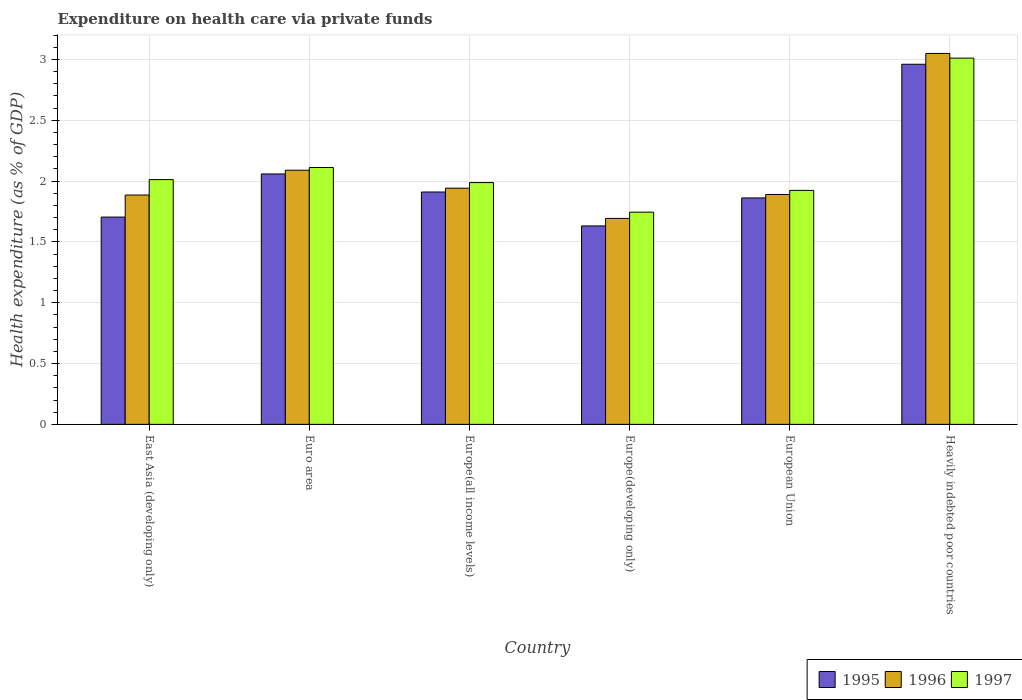How many different coloured bars are there?
Give a very brief answer. 3. Are the number of bars on each tick of the X-axis equal?
Provide a succinct answer. Yes. How many bars are there on the 6th tick from the left?
Keep it short and to the point. 3. How many bars are there on the 6th tick from the right?
Your answer should be very brief. 3. What is the label of the 1st group of bars from the left?
Offer a very short reply. East Asia (developing only). In how many cases, is the number of bars for a given country not equal to the number of legend labels?
Offer a terse response. 0. What is the expenditure made on health care in 1995 in Heavily indebted poor countries?
Offer a very short reply. 2.96. Across all countries, what is the maximum expenditure made on health care in 1996?
Offer a very short reply. 3.05. Across all countries, what is the minimum expenditure made on health care in 1995?
Offer a terse response. 1.63. In which country was the expenditure made on health care in 1995 maximum?
Your answer should be very brief. Heavily indebted poor countries. In which country was the expenditure made on health care in 1997 minimum?
Your answer should be very brief. Europe(developing only). What is the total expenditure made on health care in 1995 in the graph?
Your answer should be compact. 12.13. What is the difference between the expenditure made on health care in 1996 in Euro area and that in Europe(all income levels)?
Offer a very short reply. 0.15. What is the difference between the expenditure made on health care in 1997 in Heavily indebted poor countries and the expenditure made on health care in 1996 in Europe(all income levels)?
Provide a short and direct response. 1.07. What is the average expenditure made on health care in 1995 per country?
Provide a short and direct response. 2.02. What is the difference between the expenditure made on health care of/in 1996 and expenditure made on health care of/in 1997 in European Union?
Offer a terse response. -0.03. In how many countries, is the expenditure made on health care in 1996 greater than 0.30000000000000004 %?
Offer a terse response. 6. What is the ratio of the expenditure made on health care in 1997 in East Asia (developing only) to that in Heavily indebted poor countries?
Keep it short and to the point. 0.67. Is the expenditure made on health care in 1995 in Europe(all income levels) less than that in Europe(developing only)?
Offer a very short reply. No. What is the difference between the highest and the second highest expenditure made on health care in 1997?
Keep it short and to the point. -0.1. What is the difference between the highest and the lowest expenditure made on health care in 1996?
Provide a succinct answer. 1.36. In how many countries, is the expenditure made on health care in 1995 greater than the average expenditure made on health care in 1995 taken over all countries?
Your answer should be very brief. 2. How many bars are there?
Your answer should be compact. 18. Are all the bars in the graph horizontal?
Make the answer very short. No. How many countries are there in the graph?
Ensure brevity in your answer.  6. What is the difference between two consecutive major ticks on the Y-axis?
Provide a succinct answer. 0.5. Does the graph contain any zero values?
Provide a succinct answer. No. Does the graph contain grids?
Make the answer very short. Yes. Where does the legend appear in the graph?
Offer a terse response. Bottom right. How are the legend labels stacked?
Offer a very short reply. Horizontal. What is the title of the graph?
Make the answer very short. Expenditure on health care via private funds. Does "1987" appear as one of the legend labels in the graph?
Ensure brevity in your answer.  No. What is the label or title of the X-axis?
Make the answer very short. Country. What is the label or title of the Y-axis?
Offer a very short reply. Health expenditure (as % of GDP). What is the Health expenditure (as % of GDP) of 1995 in East Asia (developing only)?
Make the answer very short. 1.7. What is the Health expenditure (as % of GDP) in 1996 in East Asia (developing only)?
Offer a terse response. 1.89. What is the Health expenditure (as % of GDP) in 1997 in East Asia (developing only)?
Your answer should be compact. 2.01. What is the Health expenditure (as % of GDP) of 1995 in Euro area?
Your response must be concise. 2.06. What is the Health expenditure (as % of GDP) in 1996 in Euro area?
Provide a short and direct response. 2.09. What is the Health expenditure (as % of GDP) in 1997 in Euro area?
Provide a succinct answer. 2.11. What is the Health expenditure (as % of GDP) of 1995 in Europe(all income levels)?
Provide a succinct answer. 1.91. What is the Health expenditure (as % of GDP) of 1996 in Europe(all income levels)?
Your answer should be compact. 1.94. What is the Health expenditure (as % of GDP) in 1997 in Europe(all income levels)?
Give a very brief answer. 1.99. What is the Health expenditure (as % of GDP) of 1995 in Europe(developing only)?
Keep it short and to the point. 1.63. What is the Health expenditure (as % of GDP) of 1996 in Europe(developing only)?
Offer a very short reply. 1.69. What is the Health expenditure (as % of GDP) of 1997 in Europe(developing only)?
Provide a short and direct response. 1.74. What is the Health expenditure (as % of GDP) of 1995 in European Union?
Keep it short and to the point. 1.86. What is the Health expenditure (as % of GDP) of 1996 in European Union?
Ensure brevity in your answer.  1.89. What is the Health expenditure (as % of GDP) of 1997 in European Union?
Your answer should be very brief. 1.92. What is the Health expenditure (as % of GDP) in 1995 in Heavily indebted poor countries?
Keep it short and to the point. 2.96. What is the Health expenditure (as % of GDP) in 1996 in Heavily indebted poor countries?
Offer a terse response. 3.05. What is the Health expenditure (as % of GDP) of 1997 in Heavily indebted poor countries?
Your answer should be compact. 3.01. Across all countries, what is the maximum Health expenditure (as % of GDP) of 1995?
Offer a terse response. 2.96. Across all countries, what is the maximum Health expenditure (as % of GDP) of 1996?
Give a very brief answer. 3.05. Across all countries, what is the maximum Health expenditure (as % of GDP) of 1997?
Provide a succinct answer. 3.01. Across all countries, what is the minimum Health expenditure (as % of GDP) in 1995?
Provide a short and direct response. 1.63. Across all countries, what is the minimum Health expenditure (as % of GDP) of 1996?
Your answer should be very brief. 1.69. Across all countries, what is the minimum Health expenditure (as % of GDP) in 1997?
Keep it short and to the point. 1.74. What is the total Health expenditure (as % of GDP) of 1995 in the graph?
Provide a succinct answer. 12.13. What is the total Health expenditure (as % of GDP) of 1996 in the graph?
Make the answer very short. 12.55. What is the total Health expenditure (as % of GDP) in 1997 in the graph?
Provide a succinct answer. 12.79. What is the difference between the Health expenditure (as % of GDP) of 1995 in East Asia (developing only) and that in Euro area?
Offer a very short reply. -0.35. What is the difference between the Health expenditure (as % of GDP) in 1996 in East Asia (developing only) and that in Euro area?
Make the answer very short. -0.2. What is the difference between the Health expenditure (as % of GDP) in 1997 in East Asia (developing only) and that in Euro area?
Offer a very short reply. -0.1. What is the difference between the Health expenditure (as % of GDP) in 1995 in East Asia (developing only) and that in Europe(all income levels)?
Your answer should be very brief. -0.21. What is the difference between the Health expenditure (as % of GDP) in 1996 in East Asia (developing only) and that in Europe(all income levels)?
Offer a very short reply. -0.06. What is the difference between the Health expenditure (as % of GDP) of 1997 in East Asia (developing only) and that in Europe(all income levels)?
Give a very brief answer. 0.02. What is the difference between the Health expenditure (as % of GDP) of 1995 in East Asia (developing only) and that in Europe(developing only)?
Offer a terse response. 0.07. What is the difference between the Health expenditure (as % of GDP) in 1996 in East Asia (developing only) and that in Europe(developing only)?
Provide a succinct answer. 0.19. What is the difference between the Health expenditure (as % of GDP) of 1997 in East Asia (developing only) and that in Europe(developing only)?
Provide a short and direct response. 0.27. What is the difference between the Health expenditure (as % of GDP) in 1995 in East Asia (developing only) and that in European Union?
Keep it short and to the point. -0.16. What is the difference between the Health expenditure (as % of GDP) in 1996 in East Asia (developing only) and that in European Union?
Ensure brevity in your answer.  -0. What is the difference between the Health expenditure (as % of GDP) in 1997 in East Asia (developing only) and that in European Union?
Provide a short and direct response. 0.09. What is the difference between the Health expenditure (as % of GDP) in 1995 in East Asia (developing only) and that in Heavily indebted poor countries?
Ensure brevity in your answer.  -1.26. What is the difference between the Health expenditure (as % of GDP) of 1996 in East Asia (developing only) and that in Heavily indebted poor countries?
Ensure brevity in your answer.  -1.16. What is the difference between the Health expenditure (as % of GDP) in 1997 in East Asia (developing only) and that in Heavily indebted poor countries?
Your answer should be compact. -1. What is the difference between the Health expenditure (as % of GDP) in 1995 in Euro area and that in Europe(all income levels)?
Make the answer very short. 0.15. What is the difference between the Health expenditure (as % of GDP) in 1996 in Euro area and that in Europe(all income levels)?
Your answer should be compact. 0.15. What is the difference between the Health expenditure (as % of GDP) of 1997 in Euro area and that in Europe(all income levels)?
Make the answer very short. 0.12. What is the difference between the Health expenditure (as % of GDP) of 1995 in Euro area and that in Europe(developing only)?
Your answer should be compact. 0.43. What is the difference between the Health expenditure (as % of GDP) in 1996 in Euro area and that in Europe(developing only)?
Give a very brief answer. 0.4. What is the difference between the Health expenditure (as % of GDP) in 1997 in Euro area and that in Europe(developing only)?
Keep it short and to the point. 0.37. What is the difference between the Health expenditure (as % of GDP) in 1995 in Euro area and that in European Union?
Your answer should be compact. 0.2. What is the difference between the Health expenditure (as % of GDP) in 1996 in Euro area and that in European Union?
Your answer should be compact. 0.2. What is the difference between the Health expenditure (as % of GDP) in 1997 in Euro area and that in European Union?
Offer a terse response. 0.19. What is the difference between the Health expenditure (as % of GDP) in 1995 in Euro area and that in Heavily indebted poor countries?
Provide a succinct answer. -0.9. What is the difference between the Health expenditure (as % of GDP) of 1996 in Euro area and that in Heavily indebted poor countries?
Ensure brevity in your answer.  -0.96. What is the difference between the Health expenditure (as % of GDP) in 1997 in Euro area and that in Heavily indebted poor countries?
Your answer should be very brief. -0.9. What is the difference between the Health expenditure (as % of GDP) in 1995 in Europe(all income levels) and that in Europe(developing only)?
Your response must be concise. 0.28. What is the difference between the Health expenditure (as % of GDP) in 1996 in Europe(all income levels) and that in Europe(developing only)?
Ensure brevity in your answer.  0.25. What is the difference between the Health expenditure (as % of GDP) of 1997 in Europe(all income levels) and that in Europe(developing only)?
Provide a succinct answer. 0.24. What is the difference between the Health expenditure (as % of GDP) in 1995 in Europe(all income levels) and that in European Union?
Provide a short and direct response. 0.05. What is the difference between the Health expenditure (as % of GDP) of 1996 in Europe(all income levels) and that in European Union?
Provide a succinct answer. 0.05. What is the difference between the Health expenditure (as % of GDP) of 1997 in Europe(all income levels) and that in European Union?
Offer a very short reply. 0.06. What is the difference between the Health expenditure (as % of GDP) in 1995 in Europe(all income levels) and that in Heavily indebted poor countries?
Offer a terse response. -1.05. What is the difference between the Health expenditure (as % of GDP) of 1996 in Europe(all income levels) and that in Heavily indebted poor countries?
Ensure brevity in your answer.  -1.11. What is the difference between the Health expenditure (as % of GDP) in 1997 in Europe(all income levels) and that in Heavily indebted poor countries?
Give a very brief answer. -1.02. What is the difference between the Health expenditure (as % of GDP) of 1995 in Europe(developing only) and that in European Union?
Provide a short and direct response. -0.23. What is the difference between the Health expenditure (as % of GDP) in 1996 in Europe(developing only) and that in European Union?
Offer a terse response. -0.2. What is the difference between the Health expenditure (as % of GDP) in 1997 in Europe(developing only) and that in European Union?
Offer a terse response. -0.18. What is the difference between the Health expenditure (as % of GDP) of 1995 in Europe(developing only) and that in Heavily indebted poor countries?
Make the answer very short. -1.33. What is the difference between the Health expenditure (as % of GDP) of 1996 in Europe(developing only) and that in Heavily indebted poor countries?
Your answer should be very brief. -1.36. What is the difference between the Health expenditure (as % of GDP) of 1997 in Europe(developing only) and that in Heavily indebted poor countries?
Ensure brevity in your answer.  -1.27. What is the difference between the Health expenditure (as % of GDP) of 1995 in European Union and that in Heavily indebted poor countries?
Your response must be concise. -1.1. What is the difference between the Health expenditure (as % of GDP) of 1996 in European Union and that in Heavily indebted poor countries?
Keep it short and to the point. -1.16. What is the difference between the Health expenditure (as % of GDP) of 1997 in European Union and that in Heavily indebted poor countries?
Make the answer very short. -1.09. What is the difference between the Health expenditure (as % of GDP) in 1995 in East Asia (developing only) and the Health expenditure (as % of GDP) in 1996 in Euro area?
Offer a terse response. -0.39. What is the difference between the Health expenditure (as % of GDP) in 1995 in East Asia (developing only) and the Health expenditure (as % of GDP) in 1997 in Euro area?
Ensure brevity in your answer.  -0.41. What is the difference between the Health expenditure (as % of GDP) of 1996 in East Asia (developing only) and the Health expenditure (as % of GDP) of 1997 in Euro area?
Make the answer very short. -0.23. What is the difference between the Health expenditure (as % of GDP) in 1995 in East Asia (developing only) and the Health expenditure (as % of GDP) in 1996 in Europe(all income levels)?
Your response must be concise. -0.24. What is the difference between the Health expenditure (as % of GDP) of 1995 in East Asia (developing only) and the Health expenditure (as % of GDP) of 1997 in Europe(all income levels)?
Keep it short and to the point. -0.28. What is the difference between the Health expenditure (as % of GDP) in 1996 in East Asia (developing only) and the Health expenditure (as % of GDP) in 1997 in Europe(all income levels)?
Provide a short and direct response. -0.1. What is the difference between the Health expenditure (as % of GDP) of 1995 in East Asia (developing only) and the Health expenditure (as % of GDP) of 1996 in Europe(developing only)?
Your answer should be compact. 0.01. What is the difference between the Health expenditure (as % of GDP) in 1995 in East Asia (developing only) and the Health expenditure (as % of GDP) in 1997 in Europe(developing only)?
Provide a succinct answer. -0.04. What is the difference between the Health expenditure (as % of GDP) of 1996 in East Asia (developing only) and the Health expenditure (as % of GDP) of 1997 in Europe(developing only)?
Provide a succinct answer. 0.14. What is the difference between the Health expenditure (as % of GDP) in 1995 in East Asia (developing only) and the Health expenditure (as % of GDP) in 1996 in European Union?
Provide a short and direct response. -0.19. What is the difference between the Health expenditure (as % of GDP) in 1995 in East Asia (developing only) and the Health expenditure (as % of GDP) in 1997 in European Union?
Provide a short and direct response. -0.22. What is the difference between the Health expenditure (as % of GDP) of 1996 in East Asia (developing only) and the Health expenditure (as % of GDP) of 1997 in European Union?
Keep it short and to the point. -0.04. What is the difference between the Health expenditure (as % of GDP) in 1995 in East Asia (developing only) and the Health expenditure (as % of GDP) in 1996 in Heavily indebted poor countries?
Keep it short and to the point. -1.35. What is the difference between the Health expenditure (as % of GDP) of 1995 in East Asia (developing only) and the Health expenditure (as % of GDP) of 1997 in Heavily indebted poor countries?
Offer a very short reply. -1.31. What is the difference between the Health expenditure (as % of GDP) in 1996 in East Asia (developing only) and the Health expenditure (as % of GDP) in 1997 in Heavily indebted poor countries?
Your answer should be very brief. -1.13. What is the difference between the Health expenditure (as % of GDP) of 1995 in Euro area and the Health expenditure (as % of GDP) of 1996 in Europe(all income levels)?
Your answer should be very brief. 0.12. What is the difference between the Health expenditure (as % of GDP) of 1995 in Euro area and the Health expenditure (as % of GDP) of 1997 in Europe(all income levels)?
Keep it short and to the point. 0.07. What is the difference between the Health expenditure (as % of GDP) of 1996 in Euro area and the Health expenditure (as % of GDP) of 1997 in Europe(all income levels)?
Offer a very short reply. 0.1. What is the difference between the Health expenditure (as % of GDP) of 1995 in Euro area and the Health expenditure (as % of GDP) of 1996 in Europe(developing only)?
Make the answer very short. 0.37. What is the difference between the Health expenditure (as % of GDP) in 1995 in Euro area and the Health expenditure (as % of GDP) in 1997 in Europe(developing only)?
Ensure brevity in your answer.  0.31. What is the difference between the Health expenditure (as % of GDP) in 1996 in Euro area and the Health expenditure (as % of GDP) in 1997 in Europe(developing only)?
Give a very brief answer. 0.34. What is the difference between the Health expenditure (as % of GDP) of 1995 in Euro area and the Health expenditure (as % of GDP) of 1996 in European Union?
Provide a short and direct response. 0.17. What is the difference between the Health expenditure (as % of GDP) of 1995 in Euro area and the Health expenditure (as % of GDP) of 1997 in European Union?
Make the answer very short. 0.14. What is the difference between the Health expenditure (as % of GDP) in 1996 in Euro area and the Health expenditure (as % of GDP) in 1997 in European Union?
Give a very brief answer. 0.17. What is the difference between the Health expenditure (as % of GDP) of 1995 in Euro area and the Health expenditure (as % of GDP) of 1996 in Heavily indebted poor countries?
Keep it short and to the point. -0.99. What is the difference between the Health expenditure (as % of GDP) in 1995 in Euro area and the Health expenditure (as % of GDP) in 1997 in Heavily indebted poor countries?
Ensure brevity in your answer.  -0.95. What is the difference between the Health expenditure (as % of GDP) in 1996 in Euro area and the Health expenditure (as % of GDP) in 1997 in Heavily indebted poor countries?
Offer a very short reply. -0.92. What is the difference between the Health expenditure (as % of GDP) in 1995 in Europe(all income levels) and the Health expenditure (as % of GDP) in 1996 in Europe(developing only)?
Offer a terse response. 0.22. What is the difference between the Health expenditure (as % of GDP) of 1995 in Europe(all income levels) and the Health expenditure (as % of GDP) of 1997 in Europe(developing only)?
Your answer should be very brief. 0.17. What is the difference between the Health expenditure (as % of GDP) of 1996 in Europe(all income levels) and the Health expenditure (as % of GDP) of 1997 in Europe(developing only)?
Your response must be concise. 0.2. What is the difference between the Health expenditure (as % of GDP) of 1995 in Europe(all income levels) and the Health expenditure (as % of GDP) of 1996 in European Union?
Offer a very short reply. 0.02. What is the difference between the Health expenditure (as % of GDP) in 1995 in Europe(all income levels) and the Health expenditure (as % of GDP) in 1997 in European Union?
Your answer should be compact. -0.01. What is the difference between the Health expenditure (as % of GDP) in 1996 in Europe(all income levels) and the Health expenditure (as % of GDP) in 1997 in European Union?
Provide a short and direct response. 0.02. What is the difference between the Health expenditure (as % of GDP) of 1995 in Europe(all income levels) and the Health expenditure (as % of GDP) of 1996 in Heavily indebted poor countries?
Your response must be concise. -1.14. What is the difference between the Health expenditure (as % of GDP) in 1995 in Europe(all income levels) and the Health expenditure (as % of GDP) in 1997 in Heavily indebted poor countries?
Give a very brief answer. -1.1. What is the difference between the Health expenditure (as % of GDP) of 1996 in Europe(all income levels) and the Health expenditure (as % of GDP) of 1997 in Heavily indebted poor countries?
Your response must be concise. -1.07. What is the difference between the Health expenditure (as % of GDP) in 1995 in Europe(developing only) and the Health expenditure (as % of GDP) in 1996 in European Union?
Make the answer very short. -0.26. What is the difference between the Health expenditure (as % of GDP) of 1995 in Europe(developing only) and the Health expenditure (as % of GDP) of 1997 in European Union?
Your answer should be compact. -0.29. What is the difference between the Health expenditure (as % of GDP) in 1996 in Europe(developing only) and the Health expenditure (as % of GDP) in 1997 in European Union?
Your answer should be compact. -0.23. What is the difference between the Health expenditure (as % of GDP) in 1995 in Europe(developing only) and the Health expenditure (as % of GDP) in 1996 in Heavily indebted poor countries?
Your response must be concise. -1.42. What is the difference between the Health expenditure (as % of GDP) of 1995 in Europe(developing only) and the Health expenditure (as % of GDP) of 1997 in Heavily indebted poor countries?
Ensure brevity in your answer.  -1.38. What is the difference between the Health expenditure (as % of GDP) in 1996 in Europe(developing only) and the Health expenditure (as % of GDP) in 1997 in Heavily indebted poor countries?
Make the answer very short. -1.32. What is the difference between the Health expenditure (as % of GDP) in 1995 in European Union and the Health expenditure (as % of GDP) in 1996 in Heavily indebted poor countries?
Offer a very short reply. -1.19. What is the difference between the Health expenditure (as % of GDP) in 1995 in European Union and the Health expenditure (as % of GDP) in 1997 in Heavily indebted poor countries?
Offer a very short reply. -1.15. What is the difference between the Health expenditure (as % of GDP) in 1996 in European Union and the Health expenditure (as % of GDP) in 1997 in Heavily indebted poor countries?
Provide a short and direct response. -1.12. What is the average Health expenditure (as % of GDP) in 1995 per country?
Your answer should be very brief. 2.02. What is the average Health expenditure (as % of GDP) of 1996 per country?
Ensure brevity in your answer.  2.09. What is the average Health expenditure (as % of GDP) in 1997 per country?
Your response must be concise. 2.13. What is the difference between the Health expenditure (as % of GDP) in 1995 and Health expenditure (as % of GDP) in 1996 in East Asia (developing only)?
Provide a short and direct response. -0.18. What is the difference between the Health expenditure (as % of GDP) of 1995 and Health expenditure (as % of GDP) of 1997 in East Asia (developing only)?
Ensure brevity in your answer.  -0.31. What is the difference between the Health expenditure (as % of GDP) of 1996 and Health expenditure (as % of GDP) of 1997 in East Asia (developing only)?
Your response must be concise. -0.13. What is the difference between the Health expenditure (as % of GDP) in 1995 and Health expenditure (as % of GDP) in 1996 in Euro area?
Provide a succinct answer. -0.03. What is the difference between the Health expenditure (as % of GDP) of 1995 and Health expenditure (as % of GDP) of 1997 in Euro area?
Give a very brief answer. -0.05. What is the difference between the Health expenditure (as % of GDP) of 1996 and Health expenditure (as % of GDP) of 1997 in Euro area?
Your answer should be compact. -0.02. What is the difference between the Health expenditure (as % of GDP) in 1995 and Health expenditure (as % of GDP) in 1996 in Europe(all income levels)?
Provide a short and direct response. -0.03. What is the difference between the Health expenditure (as % of GDP) of 1995 and Health expenditure (as % of GDP) of 1997 in Europe(all income levels)?
Your answer should be very brief. -0.08. What is the difference between the Health expenditure (as % of GDP) in 1996 and Health expenditure (as % of GDP) in 1997 in Europe(all income levels)?
Your answer should be compact. -0.05. What is the difference between the Health expenditure (as % of GDP) of 1995 and Health expenditure (as % of GDP) of 1996 in Europe(developing only)?
Give a very brief answer. -0.06. What is the difference between the Health expenditure (as % of GDP) in 1995 and Health expenditure (as % of GDP) in 1997 in Europe(developing only)?
Give a very brief answer. -0.11. What is the difference between the Health expenditure (as % of GDP) of 1996 and Health expenditure (as % of GDP) of 1997 in Europe(developing only)?
Your answer should be compact. -0.05. What is the difference between the Health expenditure (as % of GDP) of 1995 and Health expenditure (as % of GDP) of 1996 in European Union?
Make the answer very short. -0.03. What is the difference between the Health expenditure (as % of GDP) of 1995 and Health expenditure (as % of GDP) of 1997 in European Union?
Give a very brief answer. -0.06. What is the difference between the Health expenditure (as % of GDP) of 1996 and Health expenditure (as % of GDP) of 1997 in European Union?
Keep it short and to the point. -0.03. What is the difference between the Health expenditure (as % of GDP) of 1995 and Health expenditure (as % of GDP) of 1996 in Heavily indebted poor countries?
Your answer should be very brief. -0.09. What is the difference between the Health expenditure (as % of GDP) of 1995 and Health expenditure (as % of GDP) of 1997 in Heavily indebted poor countries?
Your answer should be very brief. -0.05. What is the difference between the Health expenditure (as % of GDP) in 1996 and Health expenditure (as % of GDP) in 1997 in Heavily indebted poor countries?
Make the answer very short. 0.04. What is the ratio of the Health expenditure (as % of GDP) of 1995 in East Asia (developing only) to that in Euro area?
Give a very brief answer. 0.83. What is the ratio of the Health expenditure (as % of GDP) of 1996 in East Asia (developing only) to that in Euro area?
Keep it short and to the point. 0.9. What is the ratio of the Health expenditure (as % of GDP) in 1997 in East Asia (developing only) to that in Euro area?
Your answer should be very brief. 0.95. What is the ratio of the Health expenditure (as % of GDP) in 1995 in East Asia (developing only) to that in Europe(all income levels)?
Your answer should be compact. 0.89. What is the ratio of the Health expenditure (as % of GDP) in 1996 in East Asia (developing only) to that in Europe(all income levels)?
Offer a very short reply. 0.97. What is the ratio of the Health expenditure (as % of GDP) of 1997 in East Asia (developing only) to that in Europe(all income levels)?
Keep it short and to the point. 1.01. What is the ratio of the Health expenditure (as % of GDP) of 1995 in East Asia (developing only) to that in Europe(developing only)?
Your answer should be very brief. 1.04. What is the ratio of the Health expenditure (as % of GDP) of 1996 in East Asia (developing only) to that in Europe(developing only)?
Provide a short and direct response. 1.11. What is the ratio of the Health expenditure (as % of GDP) of 1997 in East Asia (developing only) to that in Europe(developing only)?
Keep it short and to the point. 1.15. What is the ratio of the Health expenditure (as % of GDP) in 1995 in East Asia (developing only) to that in European Union?
Your answer should be very brief. 0.92. What is the ratio of the Health expenditure (as % of GDP) in 1997 in East Asia (developing only) to that in European Union?
Keep it short and to the point. 1.05. What is the ratio of the Health expenditure (as % of GDP) in 1995 in East Asia (developing only) to that in Heavily indebted poor countries?
Provide a succinct answer. 0.58. What is the ratio of the Health expenditure (as % of GDP) of 1996 in East Asia (developing only) to that in Heavily indebted poor countries?
Provide a short and direct response. 0.62. What is the ratio of the Health expenditure (as % of GDP) in 1997 in East Asia (developing only) to that in Heavily indebted poor countries?
Provide a short and direct response. 0.67. What is the ratio of the Health expenditure (as % of GDP) in 1995 in Euro area to that in Europe(all income levels)?
Your answer should be very brief. 1.08. What is the ratio of the Health expenditure (as % of GDP) of 1996 in Euro area to that in Europe(all income levels)?
Offer a very short reply. 1.08. What is the ratio of the Health expenditure (as % of GDP) of 1997 in Euro area to that in Europe(all income levels)?
Your answer should be very brief. 1.06. What is the ratio of the Health expenditure (as % of GDP) in 1995 in Euro area to that in Europe(developing only)?
Your response must be concise. 1.26. What is the ratio of the Health expenditure (as % of GDP) of 1996 in Euro area to that in Europe(developing only)?
Provide a succinct answer. 1.23. What is the ratio of the Health expenditure (as % of GDP) of 1997 in Euro area to that in Europe(developing only)?
Provide a short and direct response. 1.21. What is the ratio of the Health expenditure (as % of GDP) in 1995 in Euro area to that in European Union?
Give a very brief answer. 1.11. What is the ratio of the Health expenditure (as % of GDP) of 1996 in Euro area to that in European Union?
Your response must be concise. 1.11. What is the ratio of the Health expenditure (as % of GDP) of 1997 in Euro area to that in European Union?
Offer a very short reply. 1.1. What is the ratio of the Health expenditure (as % of GDP) of 1995 in Euro area to that in Heavily indebted poor countries?
Your answer should be very brief. 0.7. What is the ratio of the Health expenditure (as % of GDP) in 1996 in Euro area to that in Heavily indebted poor countries?
Ensure brevity in your answer.  0.69. What is the ratio of the Health expenditure (as % of GDP) in 1997 in Euro area to that in Heavily indebted poor countries?
Make the answer very short. 0.7. What is the ratio of the Health expenditure (as % of GDP) in 1995 in Europe(all income levels) to that in Europe(developing only)?
Your answer should be compact. 1.17. What is the ratio of the Health expenditure (as % of GDP) in 1996 in Europe(all income levels) to that in Europe(developing only)?
Offer a terse response. 1.15. What is the ratio of the Health expenditure (as % of GDP) of 1997 in Europe(all income levels) to that in Europe(developing only)?
Offer a very short reply. 1.14. What is the ratio of the Health expenditure (as % of GDP) in 1995 in Europe(all income levels) to that in European Union?
Your answer should be very brief. 1.03. What is the ratio of the Health expenditure (as % of GDP) in 1996 in Europe(all income levels) to that in European Union?
Ensure brevity in your answer.  1.03. What is the ratio of the Health expenditure (as % of GDP) of 1997 in Europe(all income levels) to that in European Union?
Give a very brief answer. 1.03. What is the ratio of the Health expenditure (as % of GDP) in 1995 in Europe(all income levels) to that in Heavily indebted poor countries?
Your response must be concise. 0.65. What is the ratio of the Health expenditure (as % of GDP) of 1996 in Europe(all income levels) to that in Heavily indebted poor countries?
Give a very brief answer. 0.64. What is the ratio of the Health expenditure (as % of GDP) of 1997 in Europe(all income levels) to that in Heavily indebted poor countries?
Your answer should be compact. 0.66. What is the ratio of the Health expenditure (as % of GDP) in 1995 in Europe(developing only) to that in European Union?
Your response must be concise. 0.88. What is the ratio of the Health expenditure (as % of GDP) of 1996 in Europe(developing only) to that in European Union?
Give a very brief answer. 0.9. What is the ratio of the Health expenditure (as % of GDP) of 1997 in Europe(developing only) to that in European Union?
Offer a terse response. 0.91. What is the ratio of the Health expenditure (as % of GDP) in 1995 in Europe(developing only) to that in Heavily indebted poor countries?
Offer a very short reply. 0.55. What is the ratio of the Health expenditure (as % of GDP) of 1996 in Europe(developing only) to that in Heavily indebted poor countries?
Your answer should be very brief. 0.56. What is the ratio of the Health expenditure (as % of GDP) of 1997 in Europe(developing only) to that in Heavily indebted poor countries?
Your response must be concise. 0.58. What is the ratio of the Health expenditure (as % of GDP) in 1995 in European Union to that in Heavily indebted poor countries?
Your answer should be compact. 0.63. What is the ratio of the Health expenditure (as % of GDP) of 1996 in European Union to that in Heavily indebted poor countries?
Make the answer very short. 0.62. What is the ratio of the Health expenditure (as % of GDP) in 1997 in European Union to that in Heavily indebted poor countries?
Offer a terse response. 0.64. What is the difference between the highest and the second highest Health expenditure (as % of GDP) in 1995?
Your answer should be compact. 0.9. What is the difference between the highest and the second highest Health expenditure (as % of GDP) of 1996?
Make the answer very short. 0.96. What is the difference between the highest and the second highest Health expenditure (as % of GDP) of 1997?
Provide a short and direct response. 0.9. What is the difference between the highest and the lowest Health expenditure (as % of GDP) of 1995?
Provide a short and direct response. 1.33. What is the difference between the highest and the lowest Health expenditure (as % of GDP) in 1996?
Ensure brevity in your answer.  1.36. What is the difference between the highest and the lowest Health expenditure (as % of GDP) in 1997?
Keep it short and to the point. 1.27. 